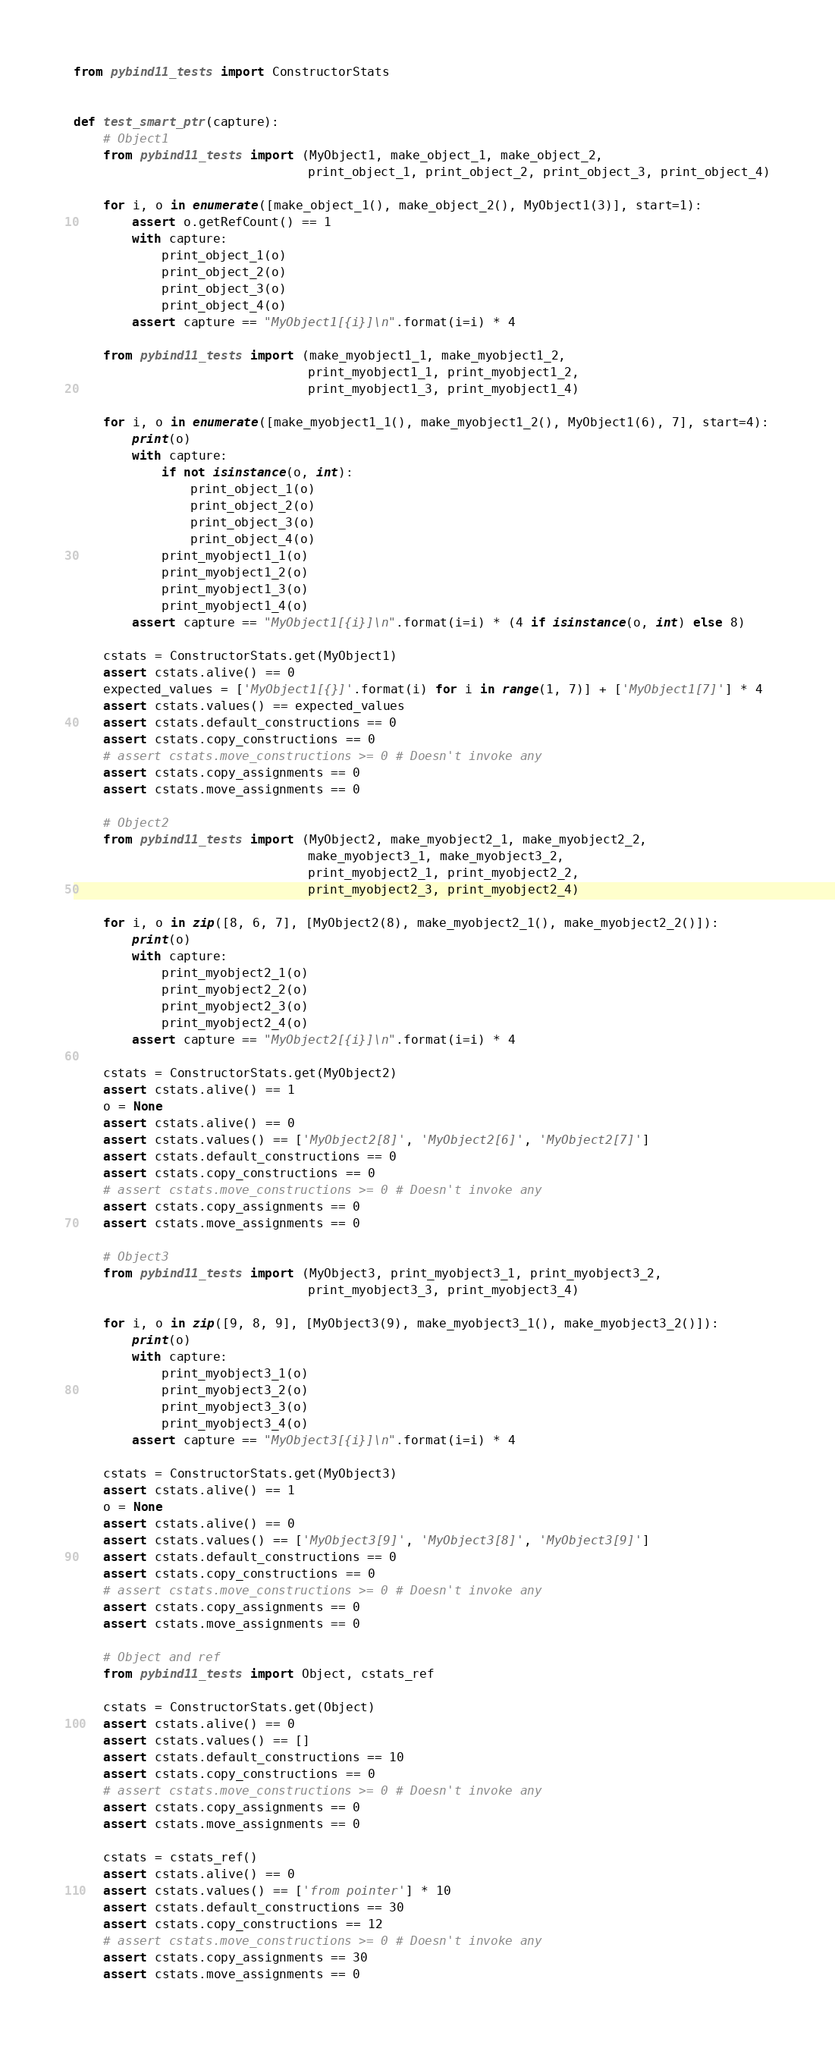Convert code to text. <code><loc_0><loc_0><loc_500><loc_500><_Python_>from pybind11_tests import ConstructorStats


def test_smart_ptr(capture):
    # Object1
    from pybind11_tests import (MyObject1, make_object_1, make_object_2,
                                print_object_1, print_object_2, print_object_3, print_object_4)

    for i, o in enumerate([make_object_1(), make_object_2(), MyObject1(3)], start=1):
        assert o.getRefCount() == 1
        with capture:
            print_object_1(o)
            print_object_2(o)
            print_object_3(o)
            print_object_4(o)
        assert capture == "MyObject1[{i}]\n".format(i=i) * 4

    from pybind11_tests import (make_myobject1_1, make_myobject1_2,
                                print_myobject1_1, print_myobject1_2,
                                print_myobject1_3, print_myobject1_4)

    for i, o in enumerate([make_myobject1_1(), make_myobject1_2(), MyObject1(6), 7], start=4):
        print(o)
        with capture:
            if not isinstance(o, int):
                print_object_1(o)
                print_object_2(o)
                print_object_3(o)
                print_object_4(o)
            print_myobject1_1(o)
            print_myobject1_2(o)
            print_myobject1_3(o)
            print_myobject1_4(o)
        assert capture == "MyObject1[{i}]\n".format(i=i) * (4 if isinstance(o, int) else 8)

    cstats = ConstructorStats.get(MyObject1)
    assert cstats.alive() == 0
    expected_values = ['MyObject1[{}]'.format(i) for i in range(1, 7)] + ['MyObject1[7]'] * 4
    assert cstats.values() == expected_values
    assert cstats.default_constructions == 0
    assert cstats.copy_constructions == 0
    # assert cstats.move_constructions >= 0 # Doesn't invoke any
    assert cstats.copy_assignments == 0
    assert cstats.move_assignments == 0

    # Object2
    from pybind11_tests import (MyObject2, make_myobject2_1, make_myobject2_2,
                                make_myobject3_1, make_myobject3_2,
                                print_myobject2_1, print_myobject2_2,
                                print_myobject2_3, print_myobject2_4)

    for i, o in zip([8, 6, 7], [MyObject2(8), make_myobject2_1(), make_myobject2_2()]):
        print(o)
        with capture:
            print_myobject2_1(o)
            print_myobject2_2(o)
            print_myobject2_3(o)
            print_myobject2_4(o)
        assert capture == "MyObject2[{i}]\n".format(i=i) * 4

    cstats = ConstructorStats.get(MyObject2)
    assert cstats.alive() == 1
    o = None
    assert cstats.alive() == 0
    assert cstats.values() == ['MyObject2[8]', 'MyObject2[6]', 'MyObject2[7]']
    assert cstats.default_constructions == 0
    assert cstats.copy_constructions == 0
    # assert cstats.move_constructions >= 0 # Doesn't invoke any
    assert cstats.copy_assignments == 0
    assert cstats.move_assignments == 0

    # Object3
    from pybind11_tests import (MyObject3, print_myobject3_1, print_myobject3_2,
                                print_myobject3_3, print_myobject3_4)

    for i, o in zip([9, 8, 9], [MyObject3(9), make_myobject3_1(), make_myobject3_2()]):
        print(o)
        with capture:
            print_myobject3_1(o)
            print_myobject3_2(o)
            print_myobject3_3(o)
            print_myobject3_4(o)
        assert capture == "MyObject3[{i}]\n".format(i=i) * 4

    cstats = ConstructorStats.get(MyObject3)
    assert cstats.alive() == 1
    o = None
    assert cstats.alive() == 0
    assert cstats.values() == ['MyObject3[9]', 'MyObject3[8]', 'MyObject3[9]']
    assert cstats.default_constructions == 0
    assert cstats.copy_constructions == 0
    # assert cstats.move_constructions >= 0 # Doesn't invoke any
    assert cstats.copy_assignments == 0
    assert cstats.move_assignments == 0

    # Object and ref
    from pybind11_tests import Object, cstats_ref

    cstats = ConstructorStats.get(Object)
    assert cstats.alive() == 0
    assert cstats.values() == []
    assert cstats.default_constructions == 10
    assert cstats.copy_constructions == 0
    # assert cstats.move_constructions >= 0 # Doesn't invoke any
    assert cstats.copy_assignments == 0
    assert cstats.move_assignments == 0

    cstats = cstats_ref()
    assert cstats.alive() == 0
    assert cstats.values() == ['from pointer'] * 10
    assert cstats.default_constructions == 30
    assert cstats.copy_constructions == 12
    # assert cstats.move_constructions >= 0 # Doesn't invoke any
    assert cstats.copy_assignments == 30
    assert cstats.move_assignments == 0
</code> 